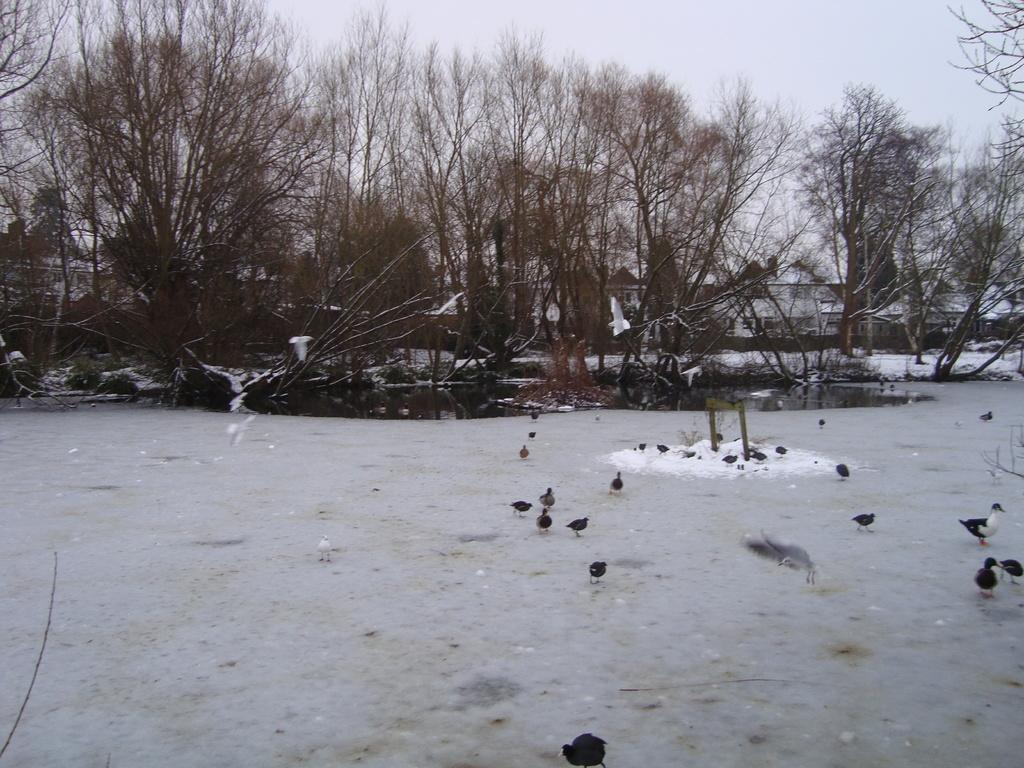What is visible in the background of the image? The sky is visible in the image. What can be seen in the sky in the image? There are clouds in the image. What type of vegetation is present in the image? There are trees in the image. What type of animals can be seen in the image? There are birds in the image. What is the weather like in the image? The presence of snow in the image suggests that it is a snowy scene. What type of surprise can be seen hidden in the clover in the image? There is no clover or surprise present in the image. Is there a camp set up in the image? There is no camp visible in the image. 